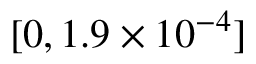<formula> <loc_0><loc_0><loc_500><loc_500>[ 0 , 1 . 9 \times 1 0 ^ { - 4 } ]</formula> 